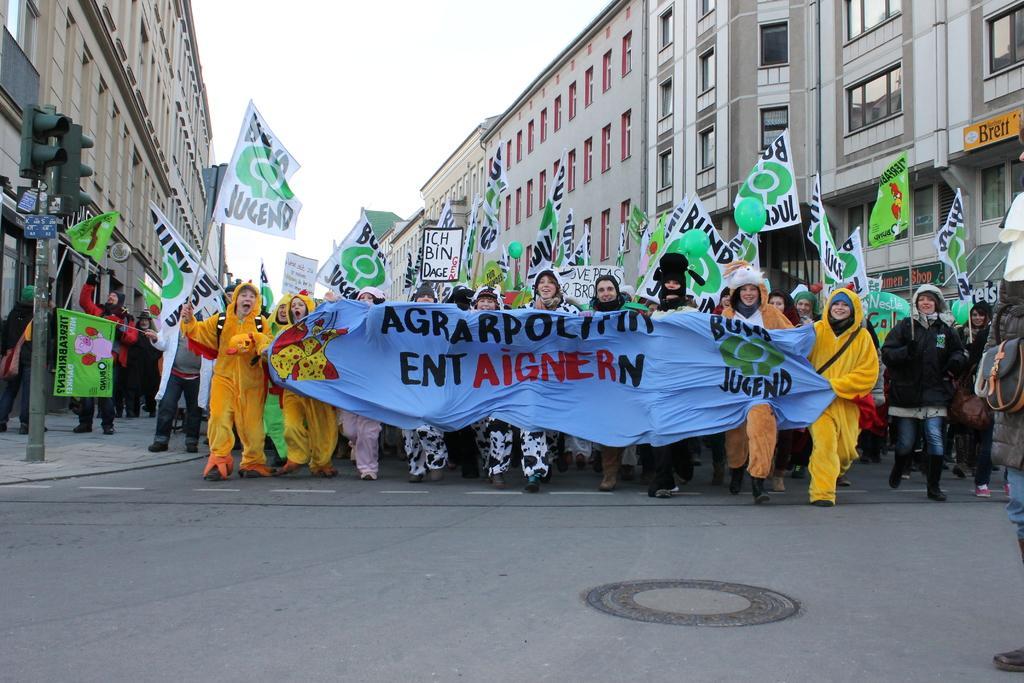Describe this image in one or two sentences. This image is taken outdoors. At the bottom of the image there is a road and a sidewalk. At the top of the image there is a sky. On the left and right sides of the image there are a few buildings with walls, windows, roofs and doors and there is a signal light on the sidewalk. In the middle of the image many people are walking on the road and they are holding many placards with text on them and a banner with a text on it. 